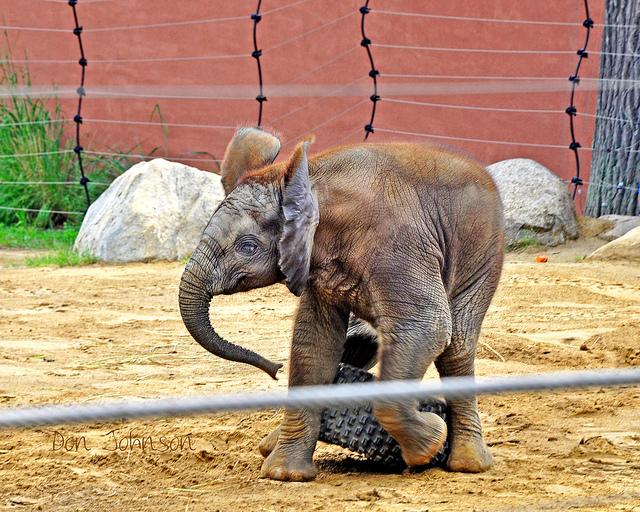Is there any grass in the picture?
Keep it brief. Yes. Where is the animal?
Write a very short answer. Zoo. Is the elephant standing on something?
Write a very short answer. Yes. 